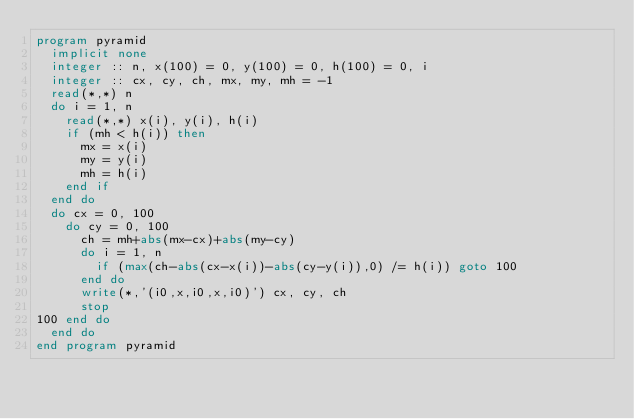<code> <loc_0><loc_0><loc_500><loc_500><_FORTRAN_>program pyramid
  implicit none
  integer :: n, x(100) = 0, y(100) = 0, h(100) = 0, i
  integer :: cx, cy, ch, mx, my, mh = -1
  read(*,*) n
  do i = 1, n
    read(*,*) x(i), y(i), h(i)
    if (mh < h(i)) then
      mx = x(i)
      my = y(i)
      mh = h(i)
    end if
  end do
  do cx = 0, 100
    do cy = 0, 100
      ch = mh+abs(mx-cx)+abs(my-cy)
      do i = 1, n
        if (max(ch-abs(cx-x(i))-abs(cy-y(i)),0) /= h(i)) goto 100
      end do
      write(*,'(i0,x,i0,x,i0)') cx, cy, ch
      stop
100 end do
  end do
end program pyramid</code> 